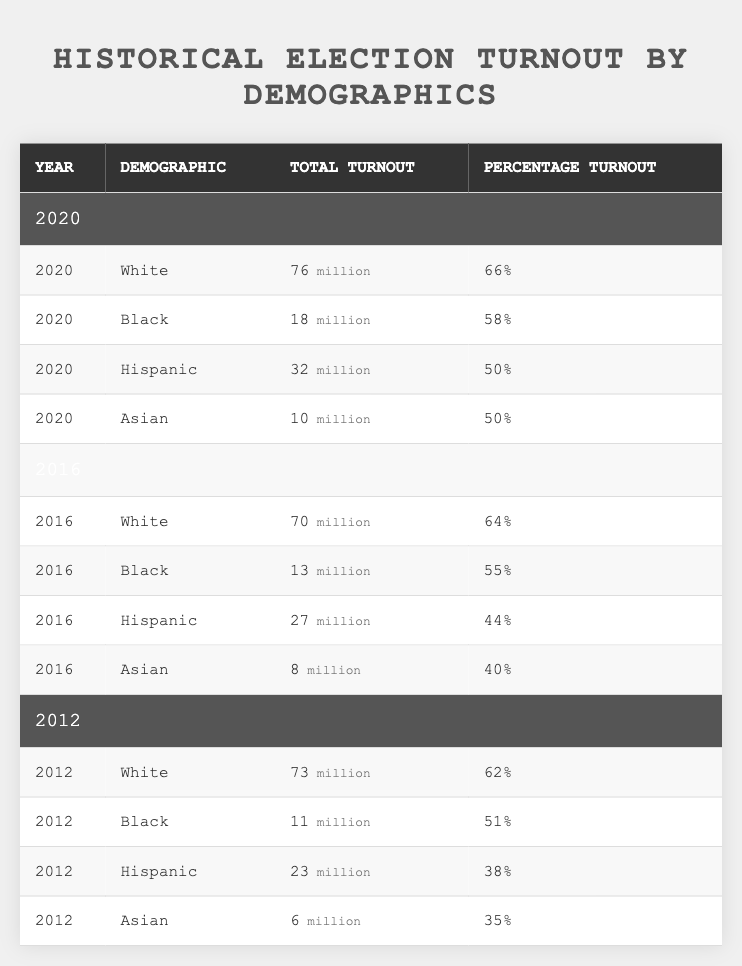What was the total turnout for Black voters in 2020? According to the table, the total turnout for Black voters in 2020 is listed as 18 million.
Answer: 18 million What is the percentage turnout for Asian voters in 2016? The table shows that the percentage turnout for Asian voters in 2016 is 40%.
Answer: 40% How many more White voters turned out in 2020 compared to 2012? The turnout for White voters in 2020 is 76 million, while in 2012 it was 73 million. The difference is 76 - 73 = 3 million.
Answer: 3 million What was the average percentage turnout for Hispanic voters across the years 2012, 2016, and 2020? The percentage turnouts for Hispanic voters are 38% in 2012, 44% in 2016, and 50% in 2020. To find the average, sum these values: 38 + 44 + 50 = 132. Then divide by 3: 132 / 3 = 44%.
Answer: 44% True or False: The turnout for Hispanic voters increased from 2012 to 2016. In 2012, Hispanic turnout was 38%, and in 2016 it was 44%. Since 44% is greater than 38%, this statement is true.
Answer: True What was the total turnout for all demographics combined in 2020? The total turnout values are 76 for White, 18 for Black, 32 for Hispanic, and 10 for Asian. Adding these gives 76 + 18 + 32 + 10 = 136 million.
Answer: 136 million Did Black voters have a higher percentage turnout in 2016 compared to Asian voters in the same year? The percentage turnout for Black voters in 2016 is 55%, while for Asian voters it is 40%. Since 55% is greater than 40%, this statement is true.
Answer: True What is the change in total turnout for White voters from 2016 to 2020? The total turnout for White voters in 2016 is 70 million, and in 2020 it is 76 million. The change is calculated as 76 - 70 = 6 million.
Answer: 6 million Which demographic had the lowest percentage turnout in 2012? In the table, the percentage turnout for each demographic in 2012 is 62% (White), 51% (Black), 38% (Hispanic), and 35% (Asian). The lowest percentage is 35% for Asian voters.
Answer: Asian voters What demographic had the highest total turnout in 2016? The table lists the total turnout for White voters as 70 million, Black voters as 13 million, Hispanic voters as 27 million, and Asian voters as 8 million. Comparing these values, White voters had the highest turnout at 70 million.
Answer: White voters 